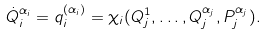Convert formula to latex. <formula><loc_0><loc_0><loc_500><loc_500>\dot { Q } _ { i } ^ { \alpha _ { i } } = q _ { i } ^ { ( \alpha _ { i } ) } = \chi _ { i } ( Q _ { j } ^ { 1 } , \dots , Q _ { j } ^ { \alpha _ { j } } , P _ { j } ^ { \alpha _ { j } } ) .</formula> 